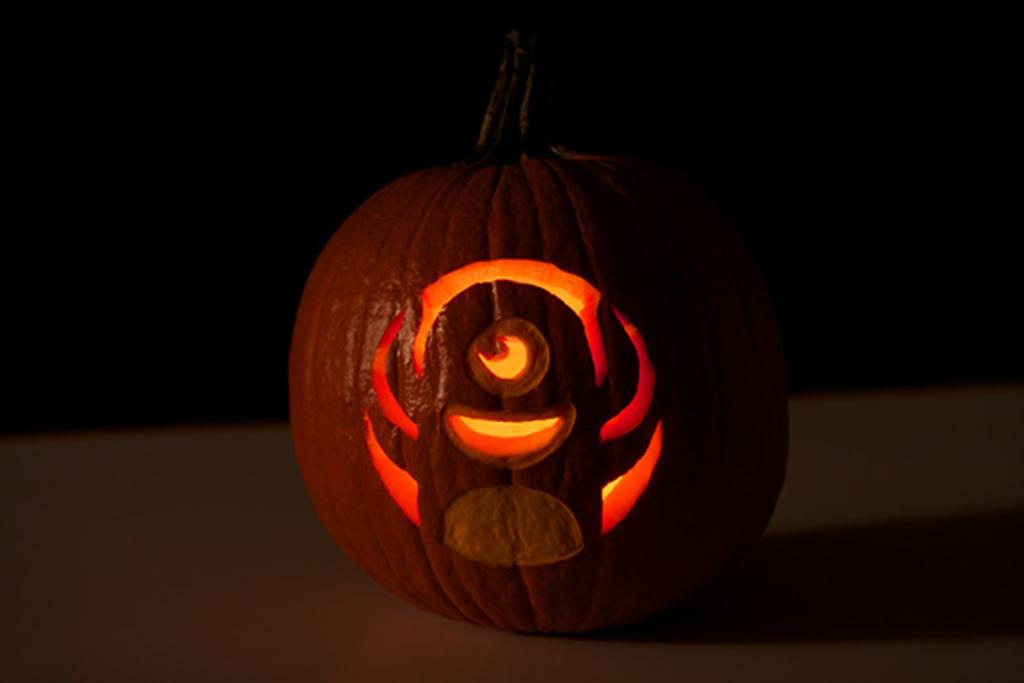What is the main object in the image? There is a pumpkin in the image. How many eyes can be seen on the pumpkin in the image? There are no eyes visible on the pumpkin in the image, as it is an inanimate object. 